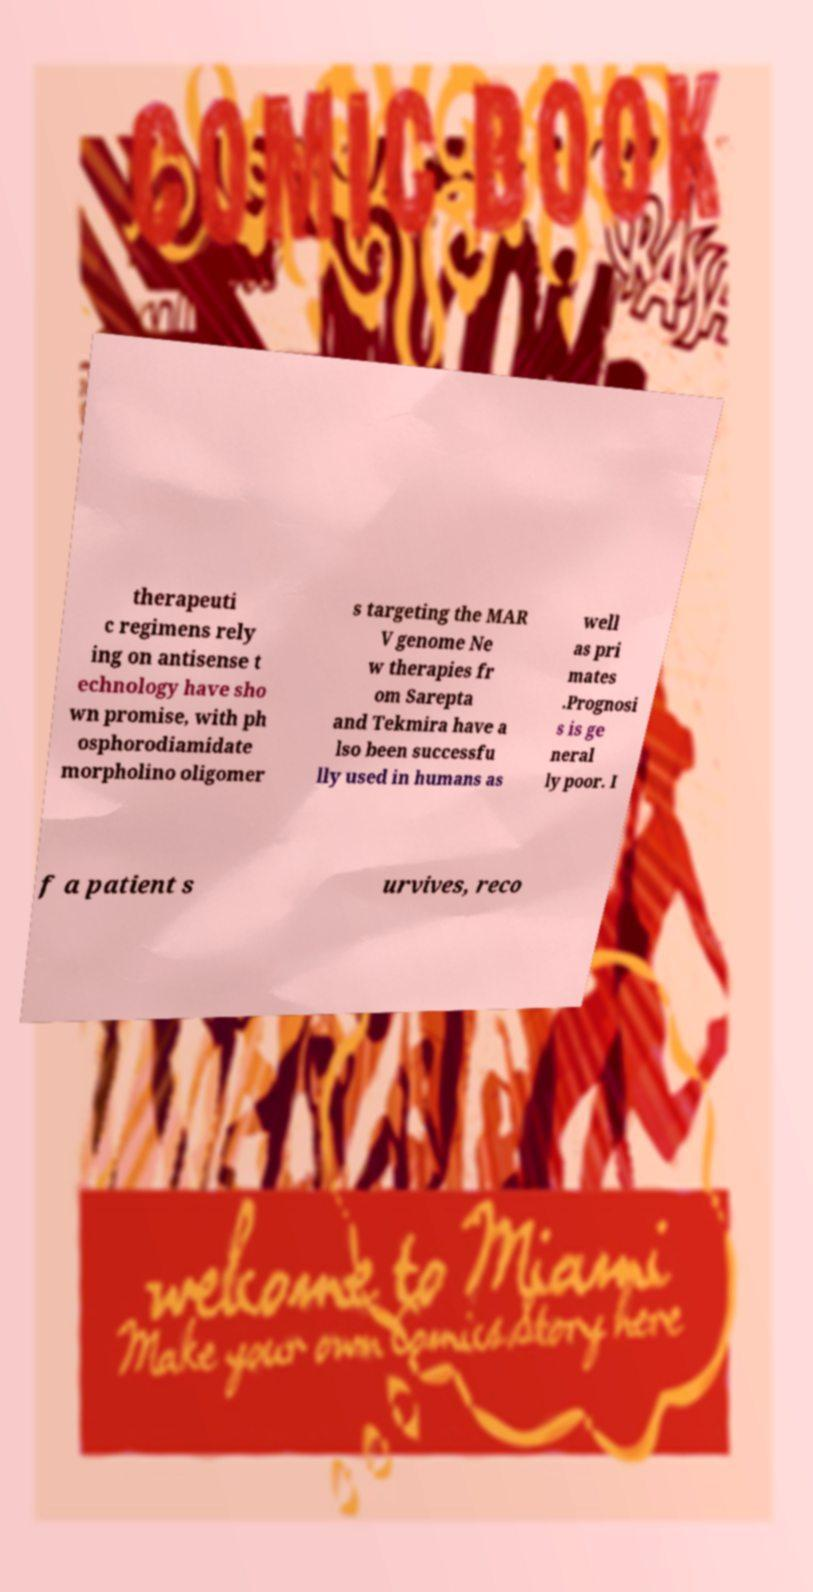Please read and relay the text visible in this image. What does it say? therapeuti c regimens rely ing on antisense t echnology have sho wn promise, with ph osphorodiamidate morpholino oligomer s targeting the MAR V genome Ne w therapies fr om Sarepta and Tekmira have a lso been successfu lly used in humans as well as pri mates .Prognosi s is ge neral ly poor. I f a patient s urvives, reco 